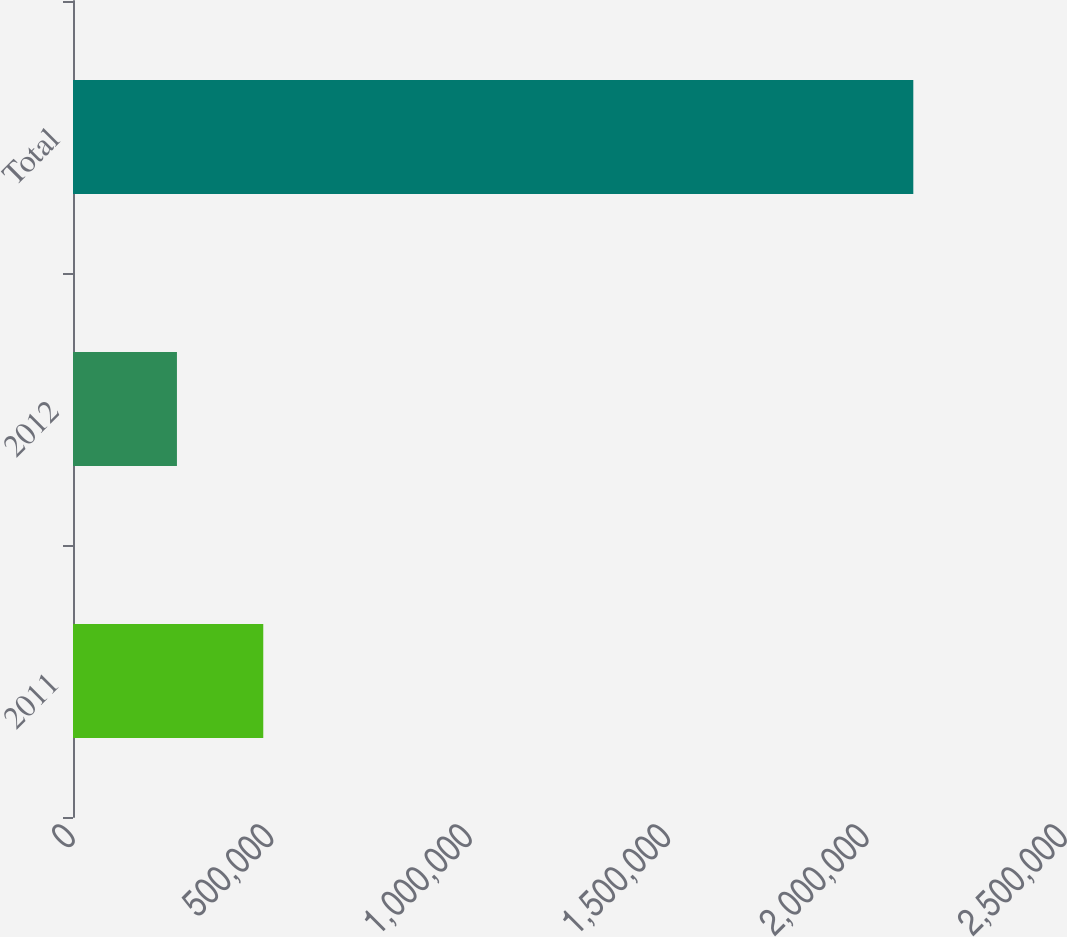Convert chart to OTSL. <chart><loc_0><loc_0><loc_500><loc_500><bar_chart><fcel>2011<fcel>2012<fcel>Total<nl><fcel>479504<fcel>261953<fcel>2.1177e+06<nl></chart> 